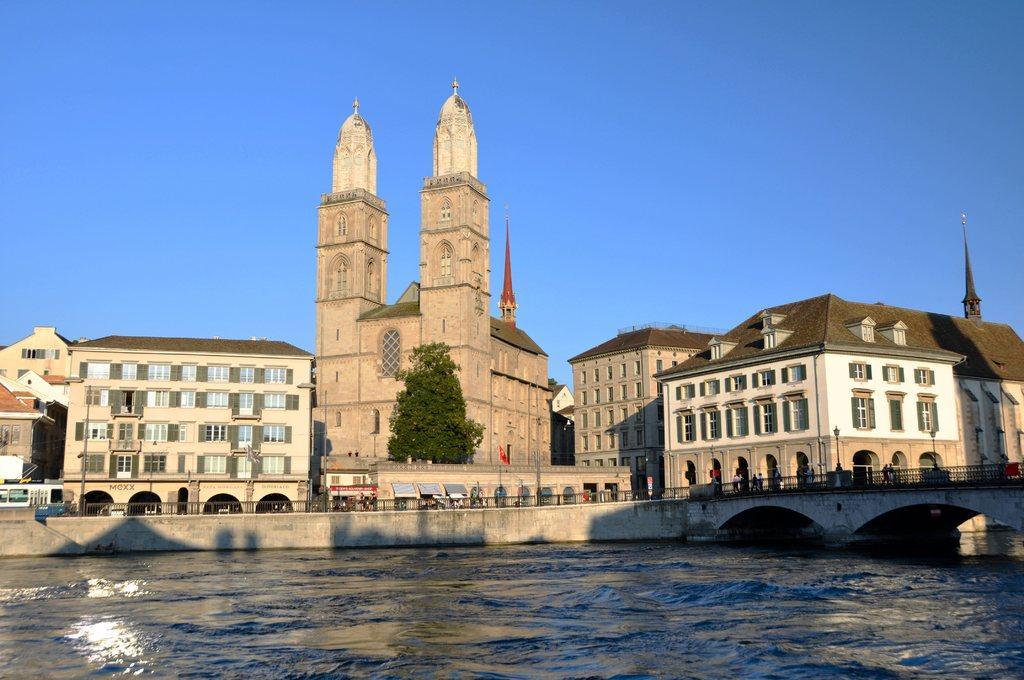Please provide a concise description of this image. In this picture we can see the lake, side we can see the road, few people are walking, behind we can see some buildings, trees. 